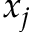Convert formula to latex. <formula><loc_0><loc_0><loc_500><loc_500>x _ { j }</formula> 